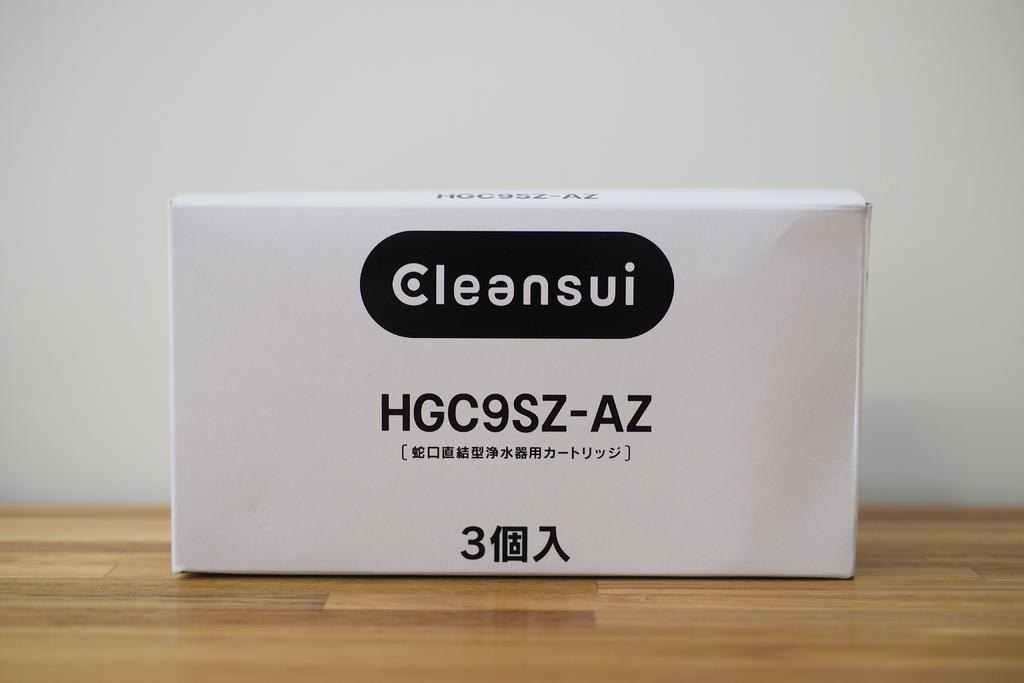<image>
Render a clear and concise summary of the photo. A white box with a Cleansui product sits on a wood surface 